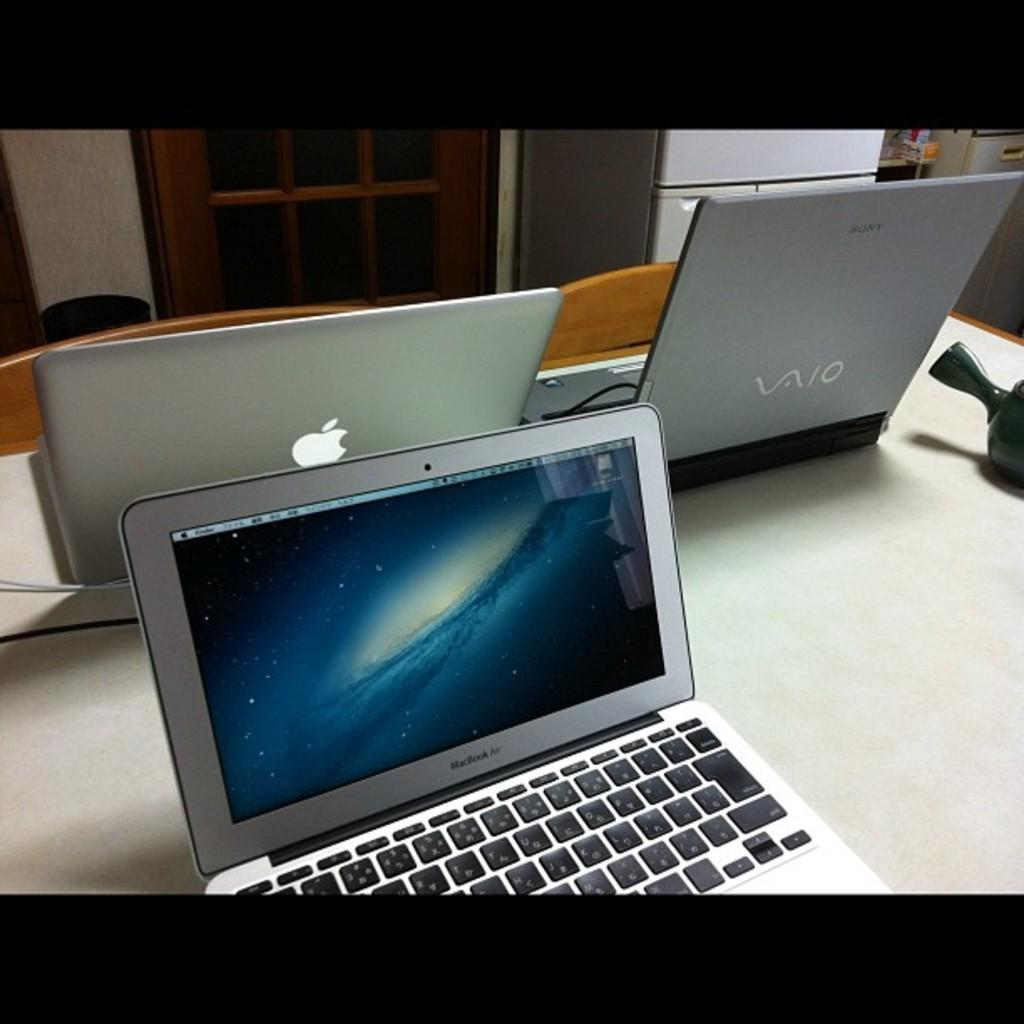<image>
Write a terse but informative summary of the picture. three silver lap top computers from companies VAIO and MacBook Air 